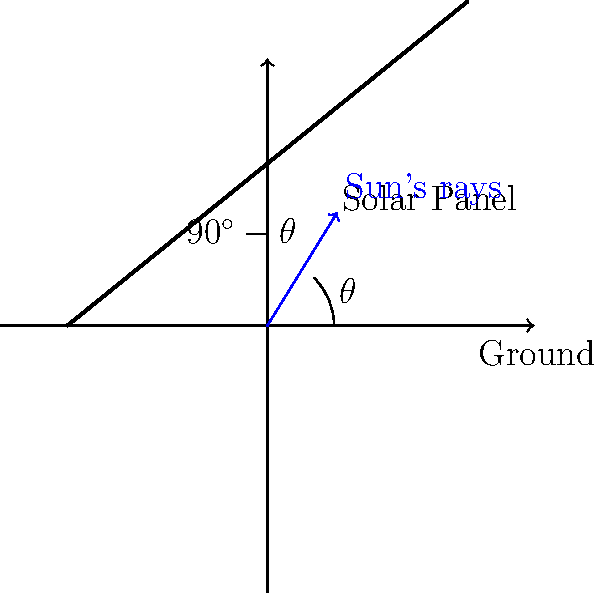As a B&B owner promoting sustainable tourism, you want to install solar panels on your roof. Given that your village is located at a latitude of 45°N, what is the optimal fixed angle (in degrees) at which you should tilt your solar panels from the horizontal to maximize energy efficiency throughout the year? To determine the optimal fixed angle for solar panels, we can follow these steps:

1. The general rule for optimal fixed solar panel tilt is that it should be approximately equal to the latitude of the location.

2. This is because the sun's position in the sky changes throughout the year, and this angle provides the best average performance.

3. In this case, the latitude is given as 45°N.

4. However, the angle we're looking for is measured from the horizontal, not from the vertical.

5. The relationship between the optimal tilt angle ($\theta$) and latitude is:

   $\theta = 90^\circ - \text{latitude}$

6. Substituting the given latitude:

   $\theta = 90^\circ - 45^\circ = 45^\circ$

Therefore, the optimal fixed angle for the solar panels in this location is 45° from the horizontal.

This angle ensures that the panels receive the maximum amount of direct sunlight throughout the year, accounting for seasonal changes in the sun's position.
Answer: 45° 